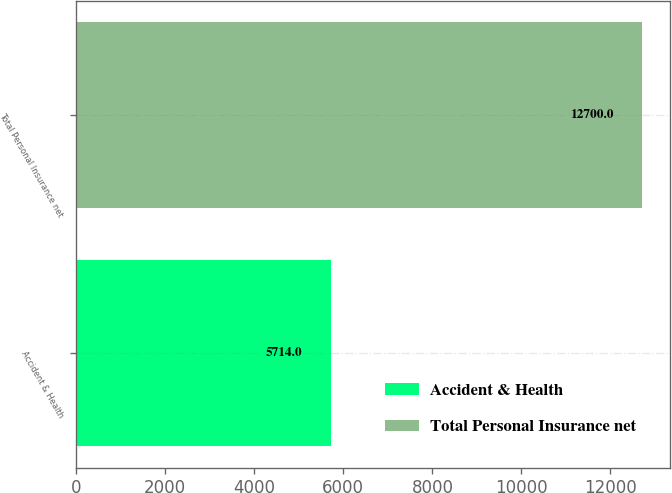Convert chart to OTSL. <chart><loc_0><loc_0><loc_500><loc_500><bar_chart><fcel>Accident & Health<fcel>Total Personal Insurance net<nl><fcel>5714<fcel>12700<nl></chart> 